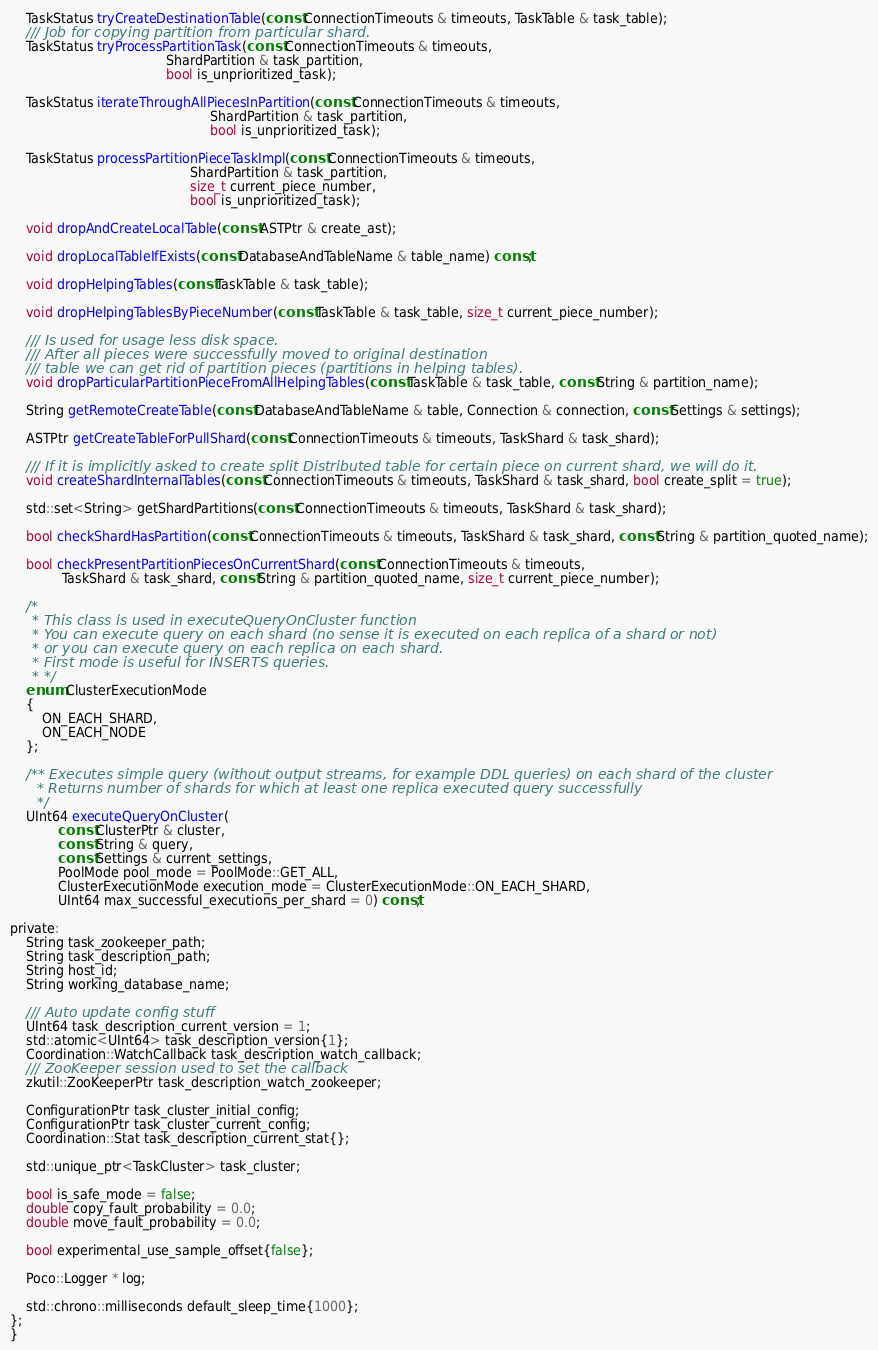<code> <loc_0><loc_0><loc_500><loc_500><_C_>
    TaskStatus tryCreateDestinationTable(const ConnectionTimeouts & timeouts, TaskTable & task_table);
    /// Job for copying partition from particular shard.
    TaskStatus tryProcessPartitionTask(const ConnectionTimeouts & timeouts,
                                       ShardPartition & task_partition,
                                       bool is_unprioritized_task);

    TaskStatus iterateThroughAllPiecesInPartition(const ConnectionTimeouts & timeouts,
                                                  ShardPartition & task_partition,
                                                  bool is_unprioritized_task);

    TaskStatus processPartitionPieceTaskImpl(const ConnectionTimeouts & timeouts,
                                             ShardPartition & task_partition,
                                             size_t current_piece_number,
                                             bool is_unprioritized_task);

    void dropAndCreateLocalTable(const ASTPtr & create_ast);

    void dropLocalTableIfExists(const DatabaseAndTableName & table_name) const;

    void dropHelpingTables(const TaskTable & task_table);

    void dropHelpingTablesByPieceNumber(const TaskTable & task_table, size_t current_piece_number);

    /// Is used for usage less disk space.
    /// After all pieces were successfully moved to original destination
    /// table we can get rid of partition pieces (partitions in helping tables).
    void dropParticularPartitionPieceFromAllHelpingTables(const TaskTable & task_table, const String & partition_name);

    String getRemoteCreateTable(const DatabaseAndTableName & table, Connection & connection, const Settings & settings);

    ASTPtr getCreateTableForPullShard(const ConnectionTimeouts & timeouts, TaskShard & task_shard);

    /// If it is implicitly asked to create split Distributed table for certain piece on current shard, we will do it.
    void createShardInternalTables(const ConnectionTimeouts & timeouts, TaskShard & task_shard, bool create_split = true);

    std::set<String> getShardPartitions(const ConnectionTimeouts & timeouts, TaskShard & task_shard);

    bool checkShardHasPartition(const ConnectionTimeouts & timeouts, TaskShard & task_shard, const String & partition_quoted_name);

    bool checkPresentPartitionPiecesOnCurrentShard(const ConnectionTimeouts & timeouts,
             TaskShard & task_shard, const String & partition_quoted_name, size_t current_piece_number);

    /*
     * This class is used in executeQueryOnCluster function
     * You can execute query on each shard (no sense it is executed on each replica of a shard or not)
     * or you can execute query on each replica on each shard.
     * First mode is useful for INSERTS queries.
     * */
    enum ClusterExecutionMode
    {
        ON_EACH_SHARD,
        ON_EACH_NODE
    };

    /** Executes simple query (without output streams, for example DDL queries) on each shard of the cluster
      * Returns number of shards for which at least one replica executed query successfully
      */
    UInt64 executeQueryOnCluster(
            const ClusterPtr & cluster,
            const String & query,
            const Settings & current_settings,
            PoolMode pool_mode = PoolMode::GET_ALL,
            ClusterExecutionMode execution_mode = ClusterExecutionMode::ON_EACH_SHARD,
            UInt64 max_successful_executions_per_shard = 0) const;

private:
    String task_zookeeper_path;
    String task_description_path;
    String host_id;
    String working_database_name;

    /// Auto update config stuff
    UInt64 task_description_current_version = 1;
    std::atomic<UInt64> task_description_version{1};
    Coordination::WatchCallback task_description_watch_callback;
    /// ZooKeeper session used to set the callback
    zkutil::ZooKeeperPtr task_description_watch_zookeeper;

    ConfigurationPtr task_cluster_initial_config;
    ConfigurationPtr task_cluster_current_config;
    Coordination::Stat task_description_current_stat{};

    std::unique_ptr<TaskCluster> task_cluster;

    bool is_safe_mode = false;
    double copy_fault_probability = 0.0;
    double move_fault_probability = 0.0;

    bool experimental_use_sample_offset{false};

    Poco::Logger * log;

    std::chrono::milliseconds default_sleep_time{1000};
};
}
</code> 